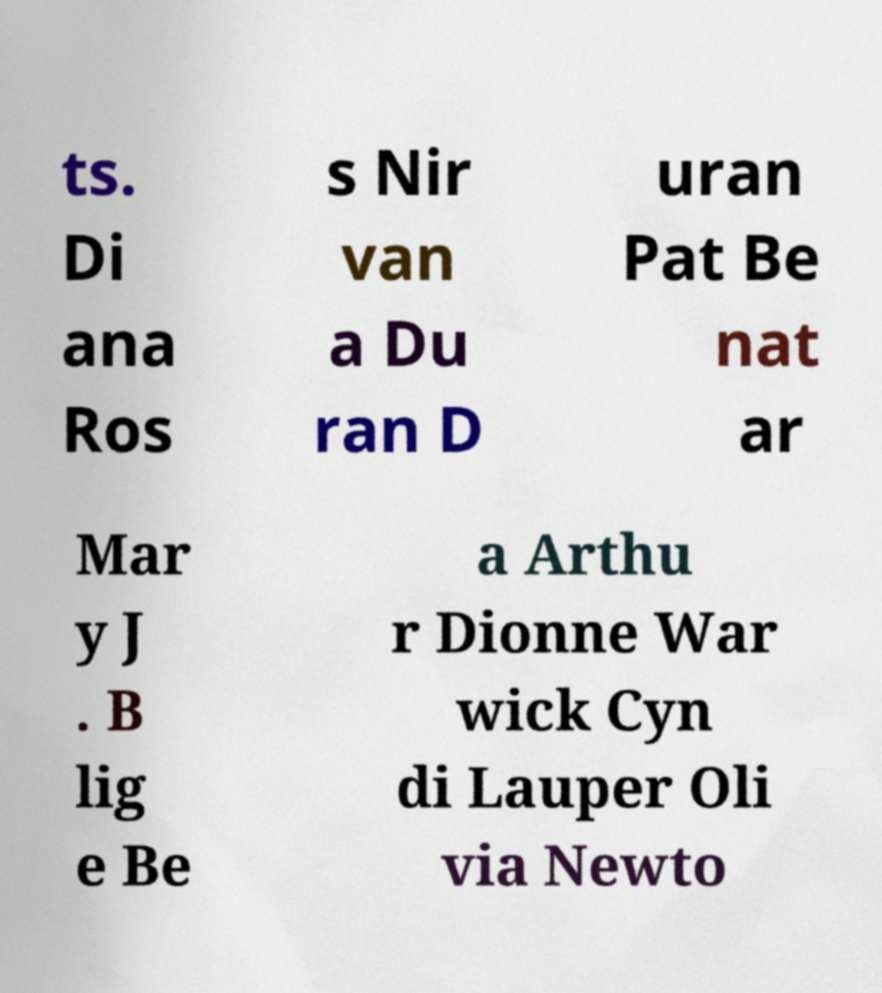Could you extract and type out the text from this image? ts. Di ana Ros s Nir van a Du ran D uran Pat Be nat ar Mar y J . B lig e Be a Arthu r Dionne War wick Cyn di Lauper Oli via Newto 